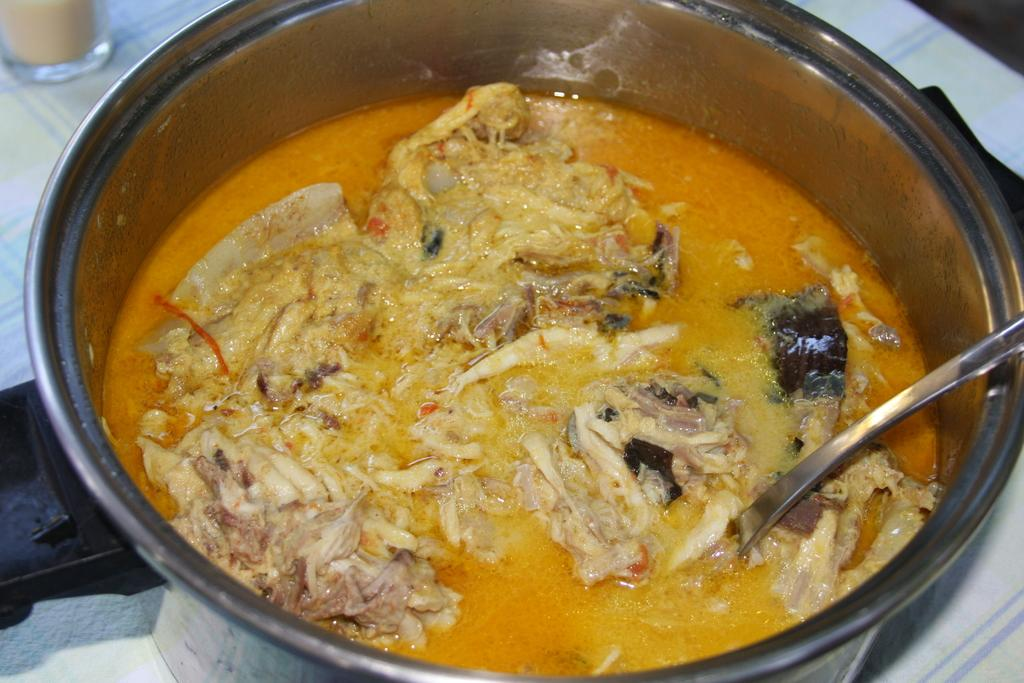What is in the bowl that is visible in the image? There is a bowl with meat soup in the image. What utensil is used to eat the soup in the image? A spoon is visible in the bowl. Where is the bowl placed in the image? The bowl is placed on a table. What type of cough can be heard in the image? There is no cough present in the image; it is a still image of a bowl with meat soup and a spoon. 